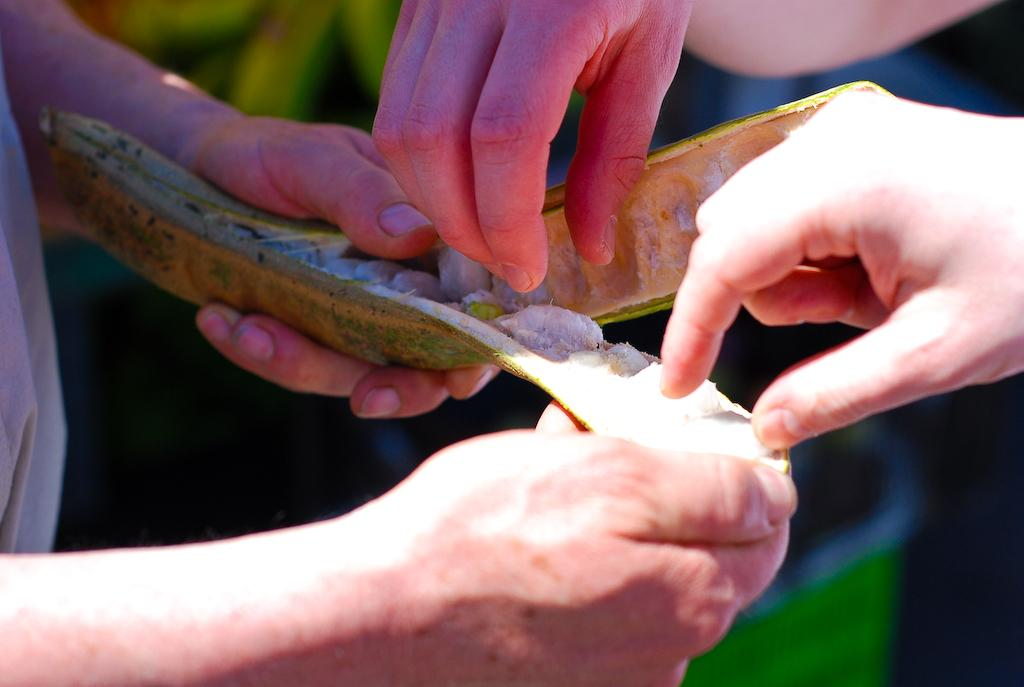What can be seen in the image involving hands? There are hands visible in the image, with one person's hands holding a green object. How many other sets of hands are present in the image? There are two other sets of hands of persons in the image. What can be inferred about the background of the image? The background of the image is blurred. What story is being read by the person in the image? There is no indication of a story or reading in the image; it only shows hands holding a green object and other hands. 